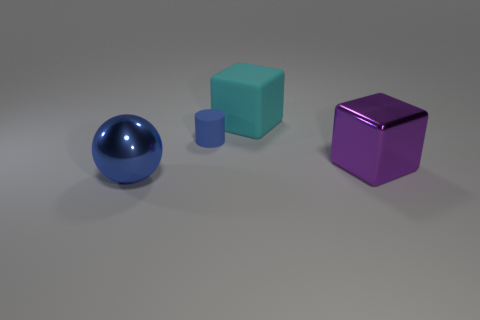How many things are blue metallic spheres or blue rubber cylinders?
Your answer should be compact. 2. What is the color of the metal thing that is the same size as the purple metal cube?
Provide a short and direct response. Blue. How many small blue cylinders are in front of the block behind the purple shiny object?
Keep it short and to the point. 1. What number of things are left of the blue rubber cylinder and on the right side of the tiny blue object?
Offer a very short reply. 0. What number of things are big metallic things that are on the left side of the big cyan rubber thing or cubes that are behind the large metallic cube?
Make the answer very short. 2. What number of other things are the same size as the cyan rubber thing?
Your answer should be compact. 2. What is the shape of the matte thing that is behind the blue thing behind the big sphere?
Make the answer very short. Cube. Do the matte thing that is on the left side of the large rubber object and the metallic object to the left of the large metallic block have the same color?
Provide a succinct answer. Yes. Is there anything else that is the same color as the metallic cube?
Offer a very short reply. No. The large matte block is what color?
Make the answer very short. Cyan. 